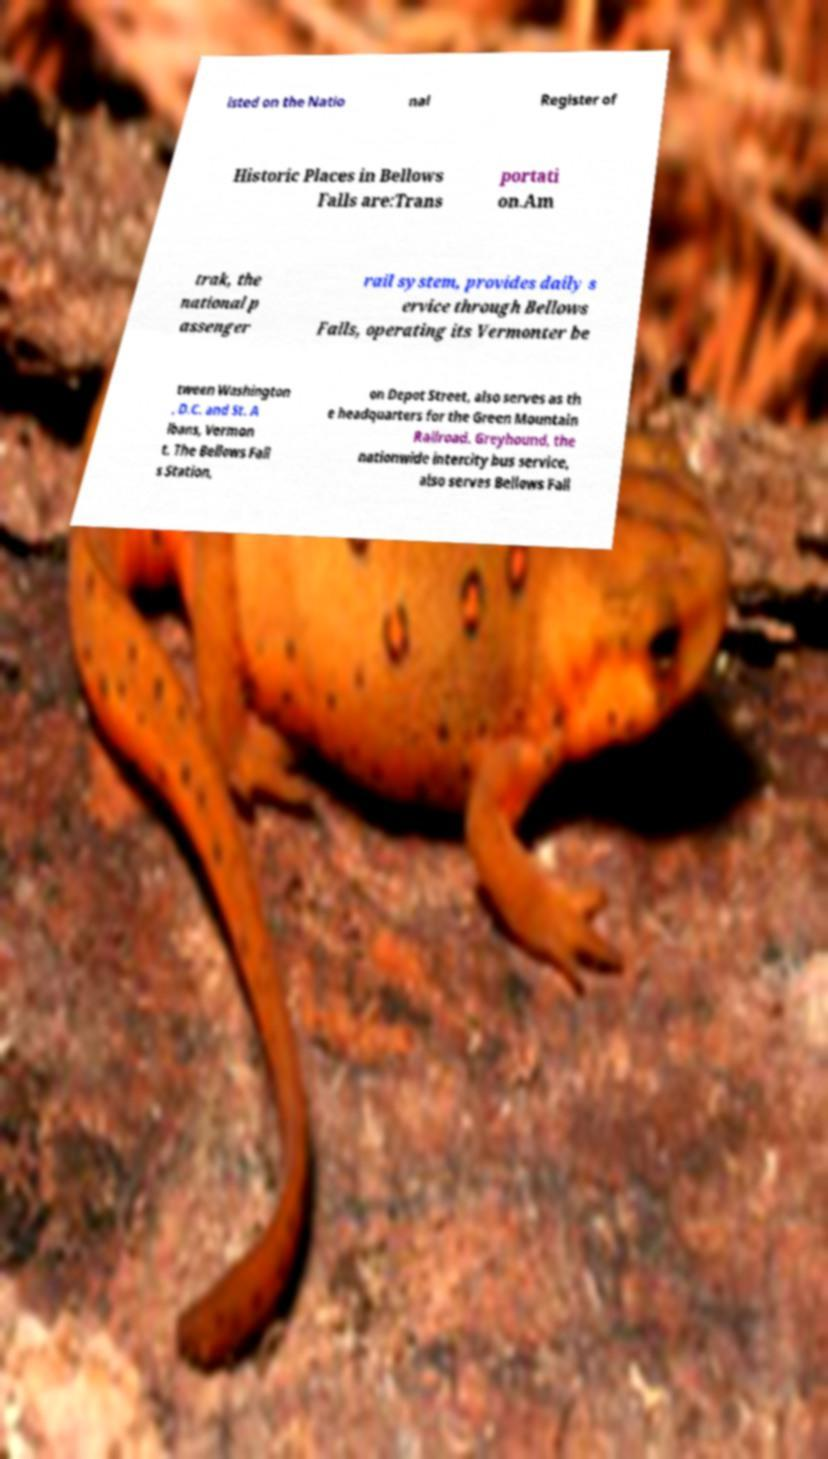What messages or text are displayed in this image? I need them in a readable, typed format. isted on the Natio nal Register of Historic Places in Bellows Falls are:Trans portati on.Am trak, the national p assenger rail system, provides daily s ervice through Bellows Falls, operating its Vermonter be tween Washington , D.C. and St. A lbans, Vermon t. The Bellows Fall s Station, on Depot Street, also serves as th e headquarters for the Green Mountain Railroad. Greyhound, the nationwide intercity bus service, also serves Bellows Fall 